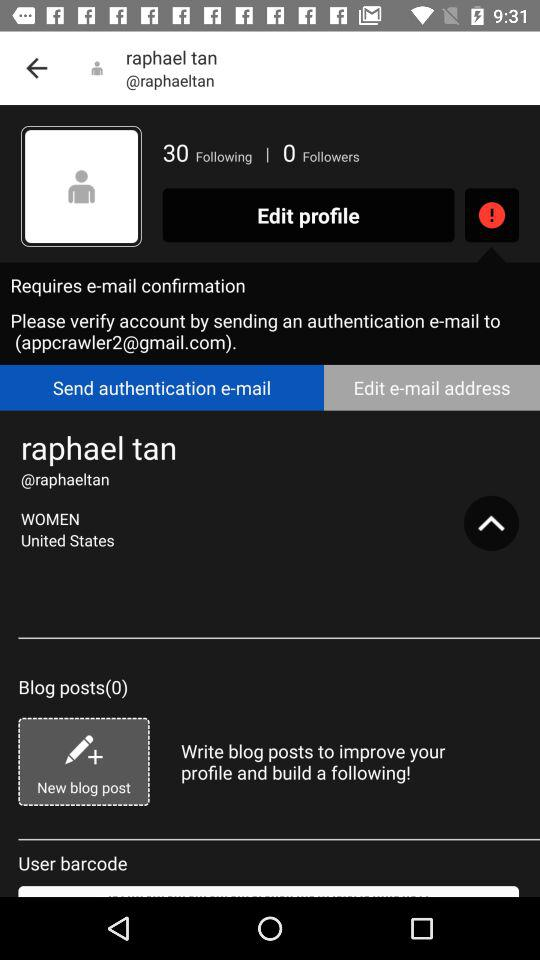How many people is Raphael Tan following? Raphael Tan is following 30 people. 